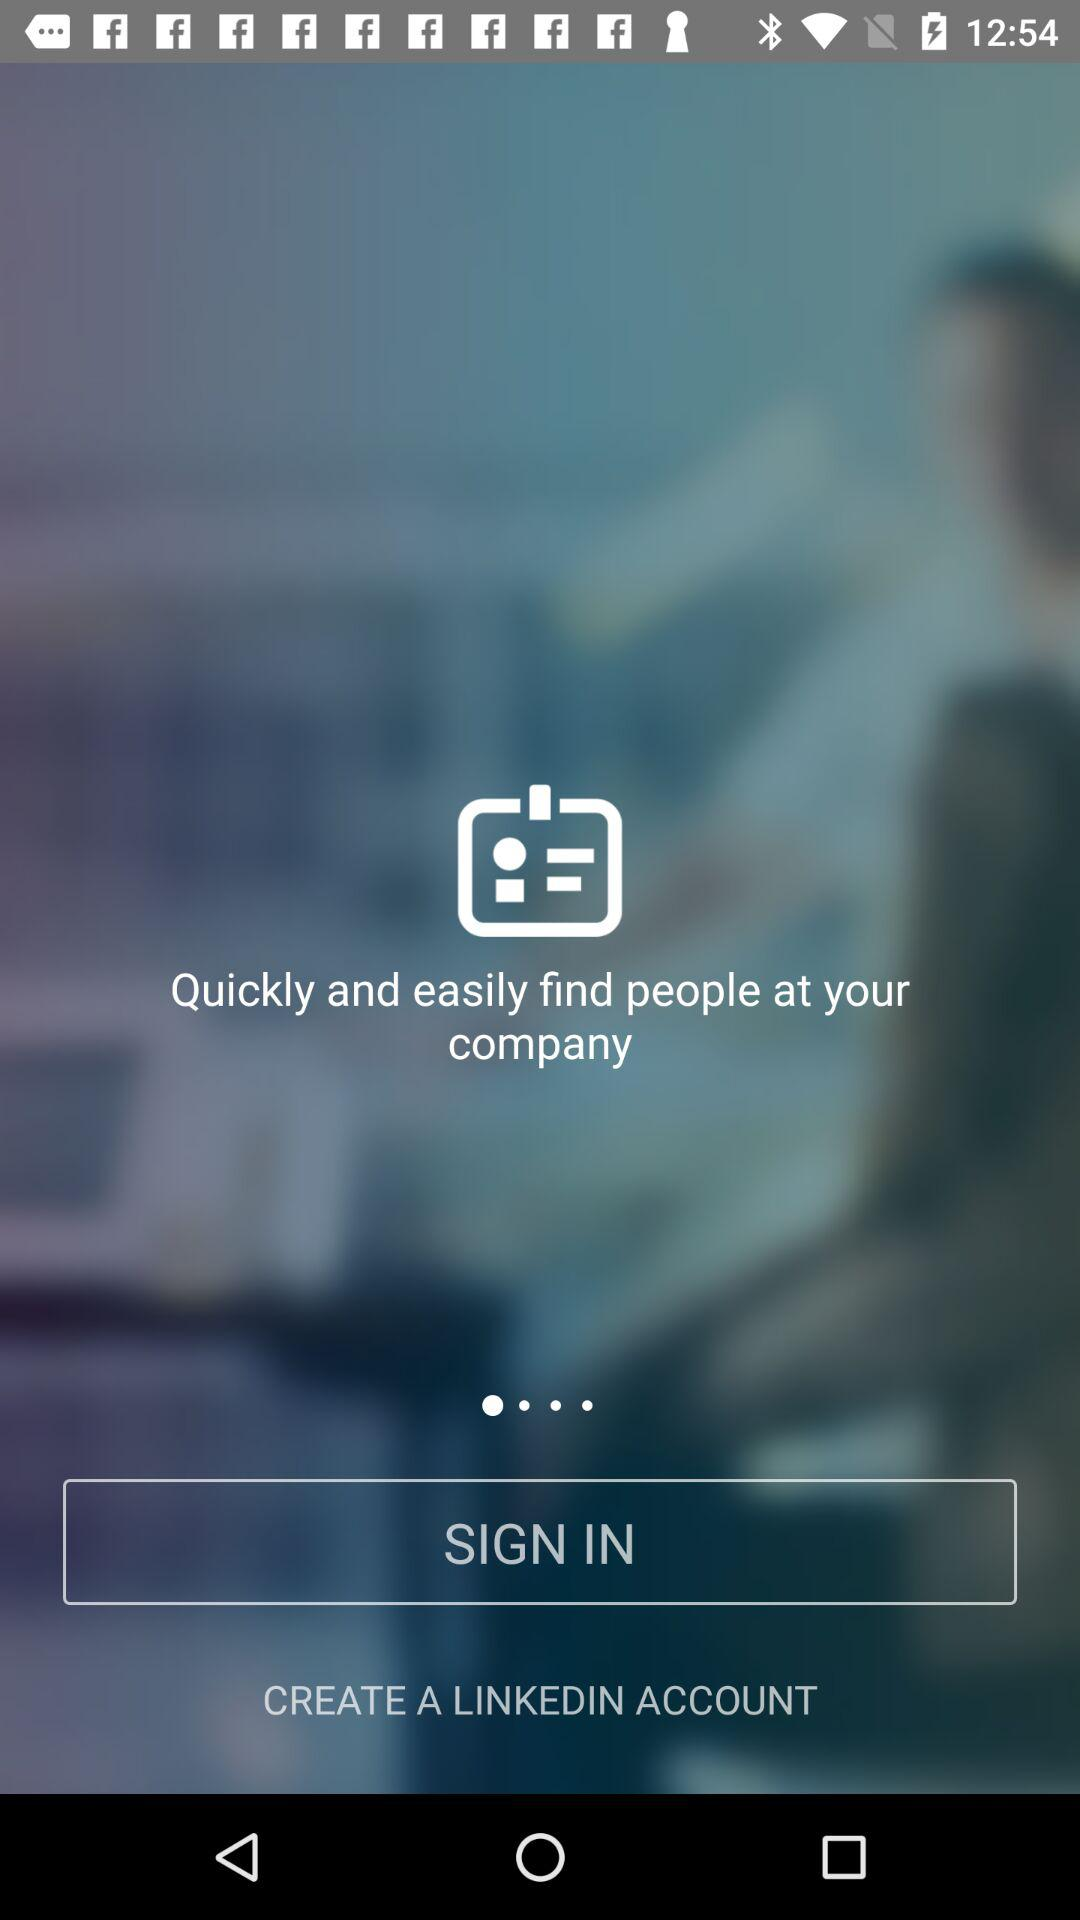What account can be created? The account that can be created is "LINKEDIN". 